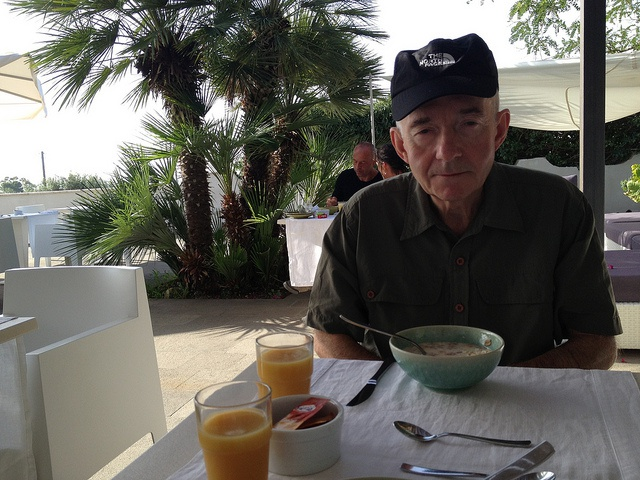Describe the objects in this image and their specific colors. I can see people in white, black, maroon, and gray tones, dining table in white, gray, black, and maroon tones, chair in white, darkgray, and gray tones, cup in white, maroon, and gray tones, and bowl in white, black, and gray tones in this image. 